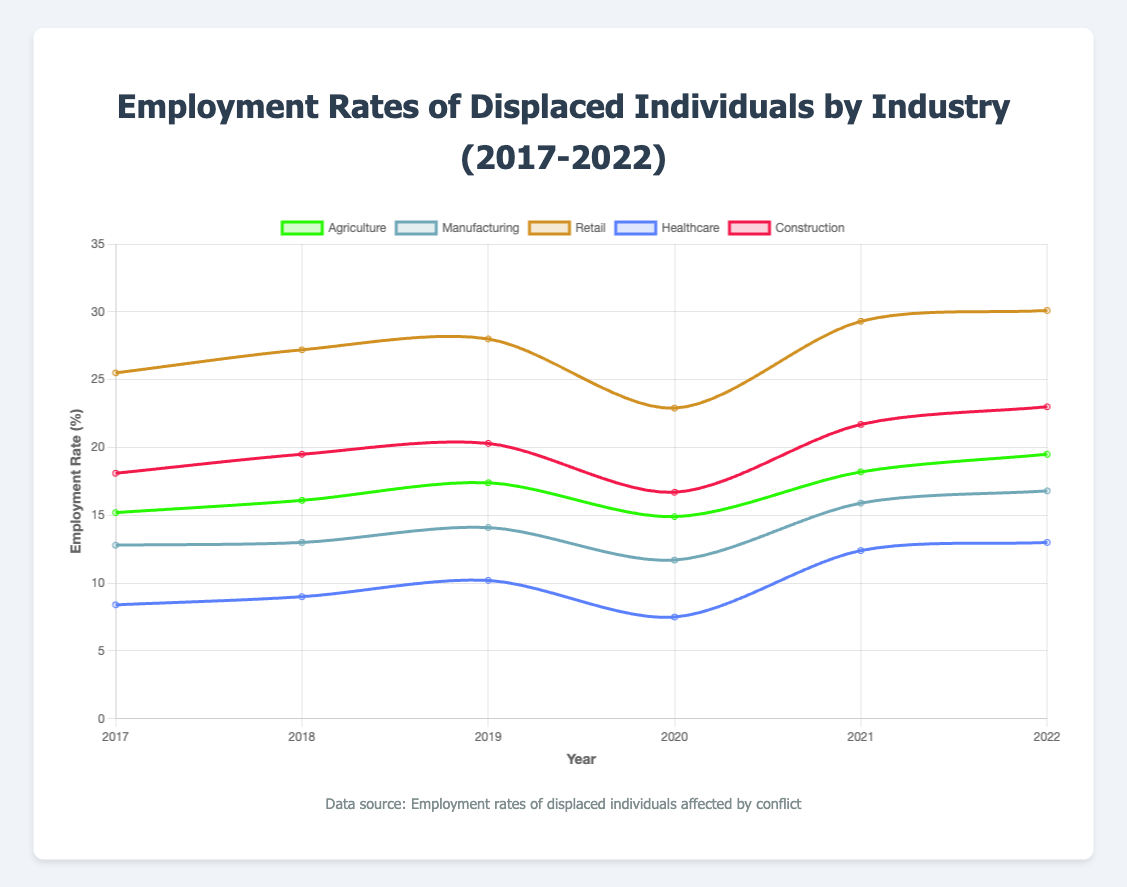Which industry had the highest employment rate in 2022? To find this, we look at the data points for each industry in the year 2022 and identify the one with the highest employment rate. From the figure, Retail has the highest rate of 30.1%.
Answer: Retail How did the employment rate in the Agriculture sector change from 2017 to 2022? Look at the line representing Agriculture and observe the values at the starting point (2017) and the ending point (2022). The rate increased from 15.2% in 2017 to 19.5% in 2022.
Answer: Increased Which industry showed the most significant decline in employment rate in 2020 compared to 2019? Compare the employment rates for each industry between 2019 and 2020. Agriculture reduced from 17.4% to 14.9%, Manufacturing from 14.1% to 11.7%, Retail from 28.0% to 22.9%, Healthcare from 10.2% to 7.5%, and Construction from 20.3% to 16.7%. Retail shows the most significant decline.
Answer: Retail Which two industries had the closest employment rates in 2018? Observe the lines for each industry in the year 2018 and find the pair with the closest employment rates. Both Manufacturing (13.0%) and Healthcare (9.0%) are relatively close, but Agriculture (16.1%) and Construction (19.5%) are closer with a difference of 3.4 percentage points.
Answer: Agriculture and Construction What's the average employment rate in the Healthcare sector from 2017 to 2022? Sum the employment rates in Healthcare for each year from 2017 to 2022: 8.4 + 9.0 + 10.2 + 7.5 + 12.4 + 13.0 = 60.5, then divide by the number of years (6) to get the average.
Answer: 10.08 Which year did the Construction sector see the highest increase in employment rate compared to the previous year? Look at the line for the Construction sector and evaluate the differences between consecutive years. From 2017 to 2018, the increase is 1.4%; from 2018 to 2019, 0.8%; from 2019 to 2020, a decrease; from 2020 to 2021, an increase of 5%; from 2021 to 2022, an increase of 1.3%. The highest increase is from 2020 to 2021.
Answer: 2021 How did the employment rate in Retail change over the years? Observe the trend line for Retail from 2017 to 2022. Note the values: 2017 (25.5%), 2018 (27.2%), 2019 (28.0%), 2020 (22.9%), 2021 (29.3%), 2022 (30.1%). The rates generally increased except for 2020, which had a drop.
Answer: Mostly increased, with a drop in 2020 In which year did Healthcare first surpass 10% employment rate? Look at the line corresponding to Healthcare and identify the year it first exceeds the 10% mark. The rate surpasses 10% for the first time in 2019.
Answer: 2019 What is the employment rate difference between Agriculture and Manufacturing in 2022? Find the employment rates for Agriculture (19.5%) and Manufacturing (16.8%) in 2022 and compute the difference: 19.5% - 16.8% = 2.7%.
Answer: 2.7% 